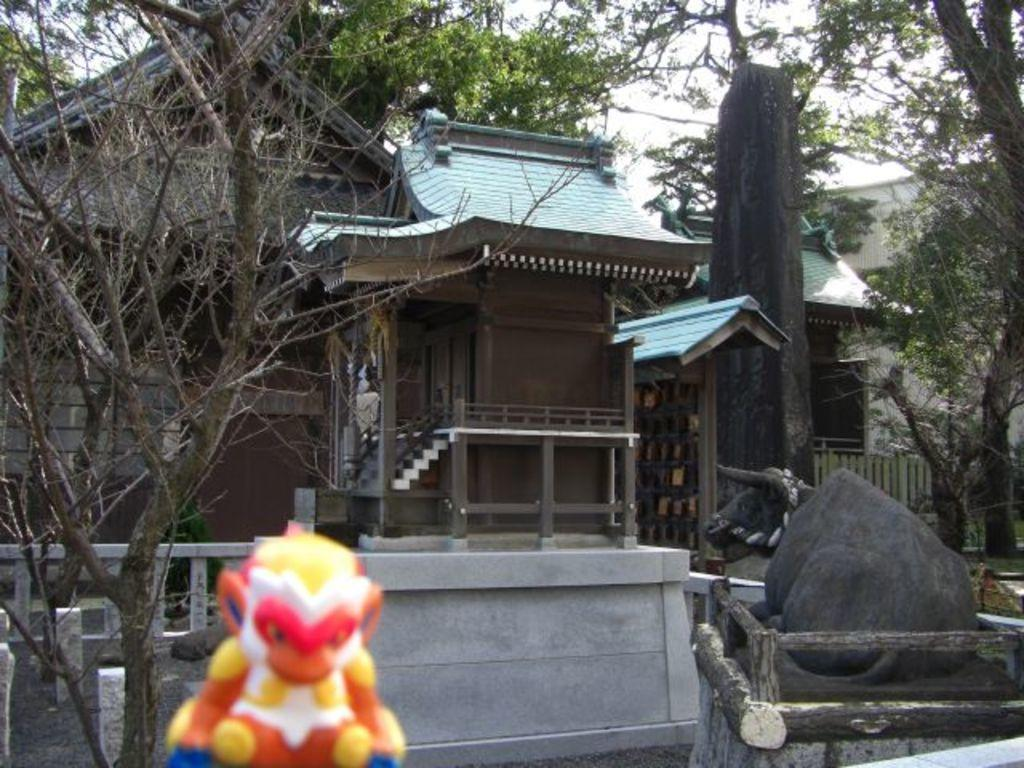What type of structures can be seen in the image? There are houses in the image. What architectural features are present in the image? Railings, fencing, stairs, pillars, and walls are visible in the image. What natural elements are present in the image? Trees are present in the image. What object is at the bottom of the image? A toy is at the bottom of the image. What other objects can be seen in the image? There are poles in the image. Are there any animals present in the image? Yes, a buffalo is in the image. How many sisters are present in the image? There is no mention of a sister in the image, so we cannot determine the number of sisters present. What type of clam can be seen in the image? There is no clam present in the image. 